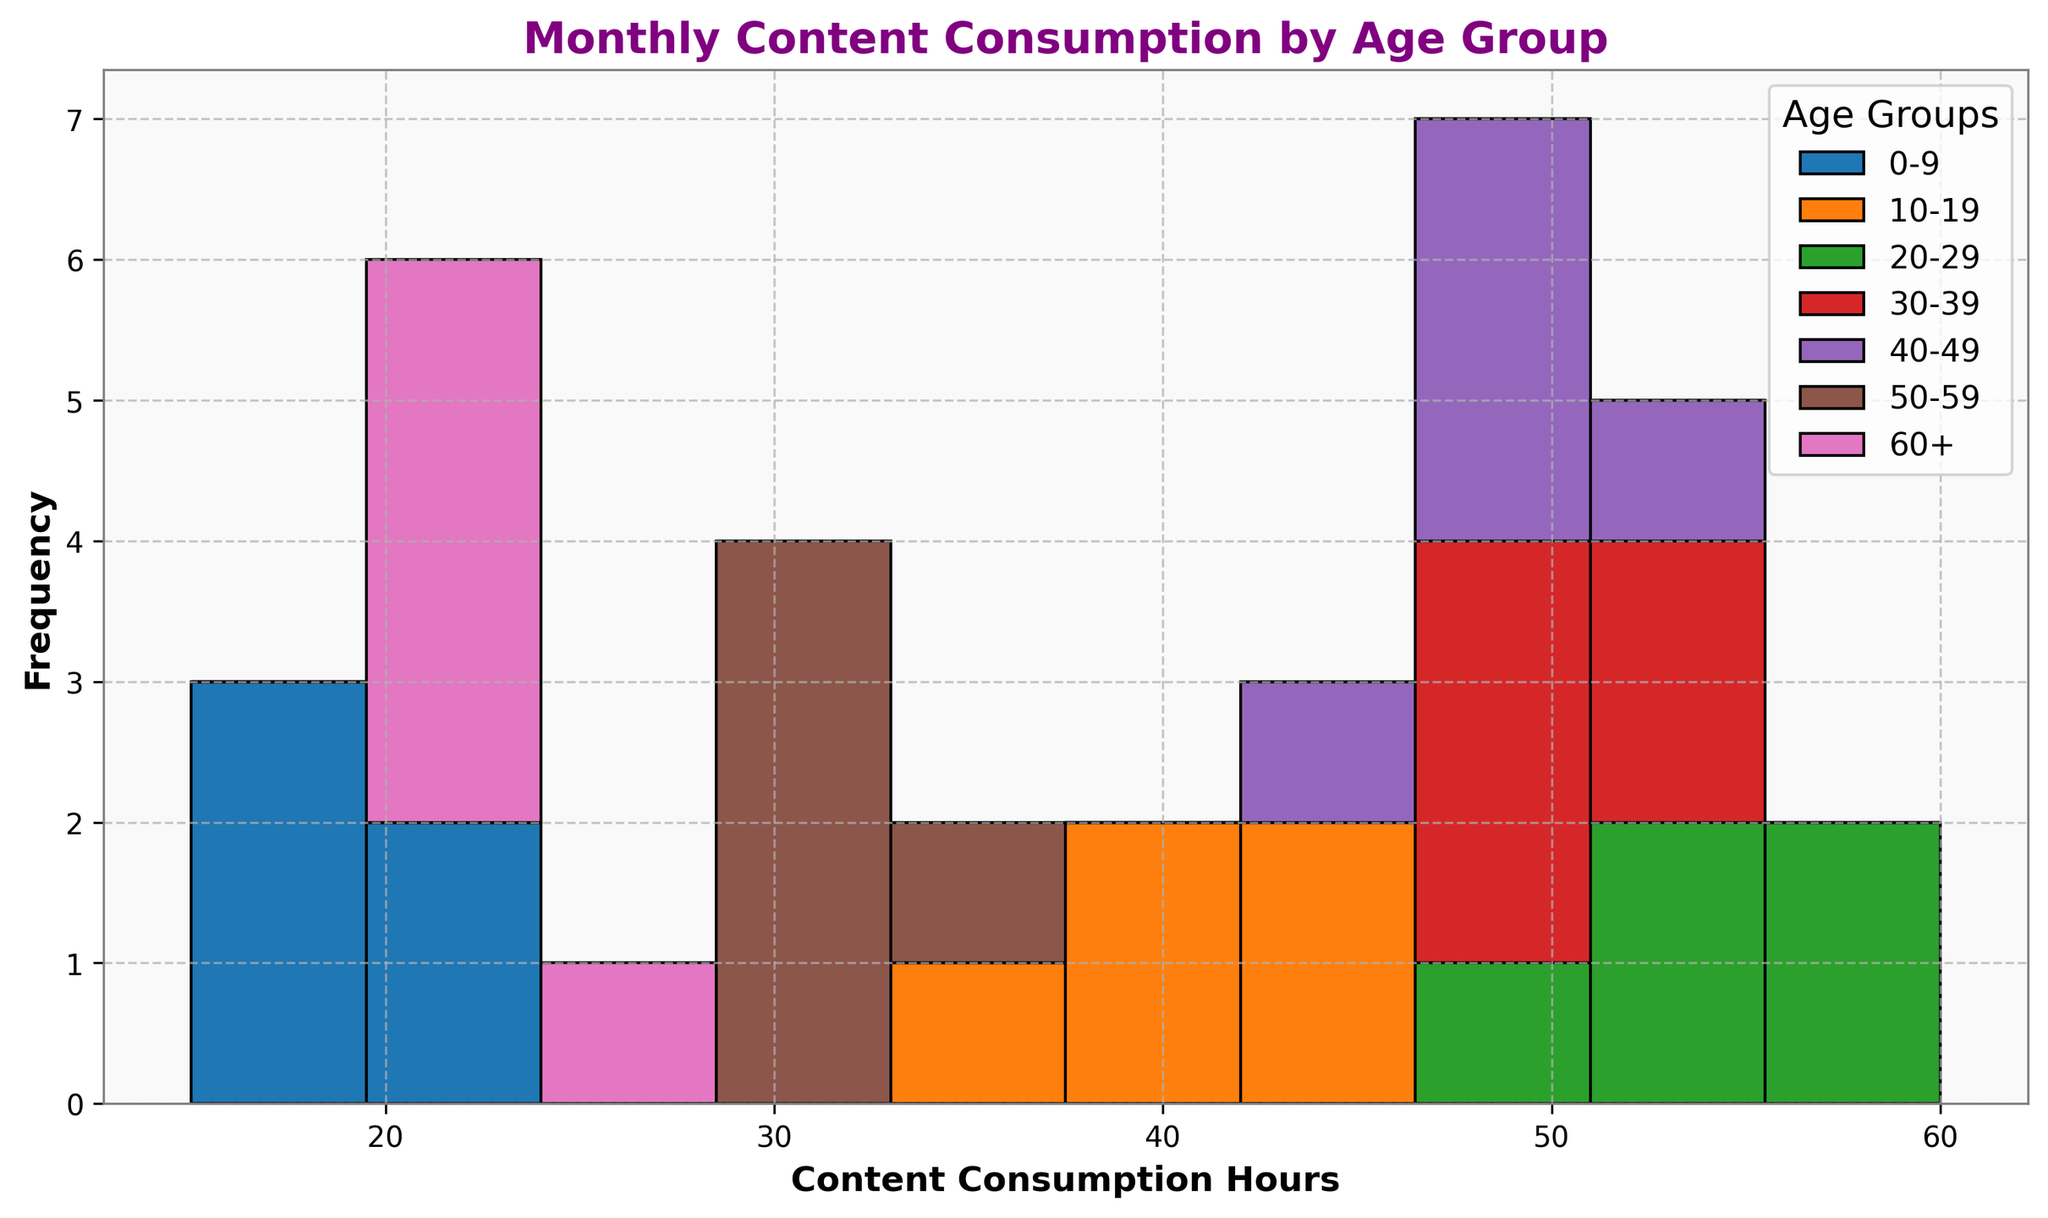Which age group has the highest frequency of monthly content consumption above 50 hours? By examining the histogram, observe the height of the bars representing the frequency of content consumption above 50 hours for each age group. Notice that the 20-29 age group has the highest frequency in this range.
Answer: 20-29 Are there any age groups that have no data points above 50 hours of monthly content consumption? Refer to the histogram to check if there are age groups with zero bars or heights representing data points above 50 hours. Notice that the 0-9 and 60+ age groups have no data points above 50 hours.
Answer: 0-9, 60+ Compare the frequency of content consumption between the 40-49 and 50-59 age groups for the 30-40 hour segment. In the 30-40 hour segment, look at the height of the bars for both the 40-49 and 50-59 age groups. The histogram shows that the 50-59 age group has a higher frequency in this segment than the 40-49 age group.
Answer: 50-59 What age group has the widest range of monthly content consumption hours? Check which age group spans the broadest range of content consumption hours along the x-axis by looking at the spread of their bars. The 20-29 age group has the widest range, spanning from 50 to 60+ hours.
Answer: 20-29 What is the dominant age group for monthly content consumption around 35 hours? Identify the highest bar in the histogram around the 35-hour mark and observe to which age group it belongs. The 10-19 age group dominates this mark.
Answer: 10-19 Which age group displays the least variation in monthly content consumption hours? Analyze the spread of frequencies (bars) across the x-axis. The 60+ age group displays the least variation, primarily occupying a small range between 20 and 25 hours.
Answer: 60+ How do the consumption frequencies of the 0-9 and 10-19 age groups compare between 15 and 25 hours? Examine the chart for these two age groups within the 15 to 25-hour range, comparing the height of the bars. The 0-9 age group shows higher frequencies in this range.
Answer: 0-9 What trends can be observed in content consumption hours as age increases? Observing the histogram, note how consumption hours increase with age until 20-29, then gradually decrease in older age groups, with the highest consumption seen in the 20-29 age group and the least in 60+.
Answer: Increases to 20-29, then decreases What is the combined frequency for content consumption below 30 hours for the 50-59 and 60+ age groups? Sum the bar heights representing frequencies below 30 hours for both age groups. The 50-59 group has some frequencies below 30, and the 60+ group has all frequencies below 30. Summing these gives the combined frequency.
Answer: Combined frequencies for 50-59 and all for 60+ What is the frequency difference for 45-50 hours between the 30-39 and 40-49 age groups? Compare the height of the bars in the 45-50 hour range for these age groups. Calculate the height difference between them. The 40-49 group shows slightly higher frequency bars than 30-39.
Answer: 40-49 higher than 30-39 